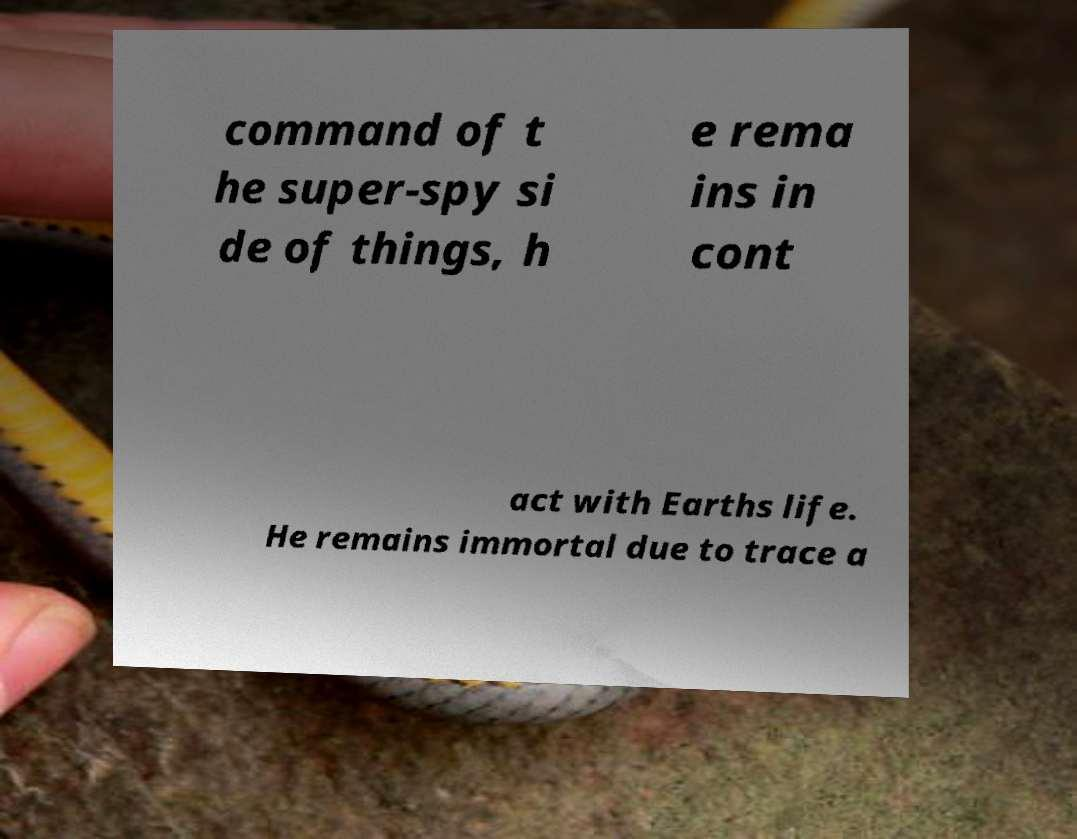Could you assist in decoding the text presented in this image and type it out clearly? command of t he super-spy si de of things, h e rema ins in cont act with Earths life. He remains immortal due to trace a 